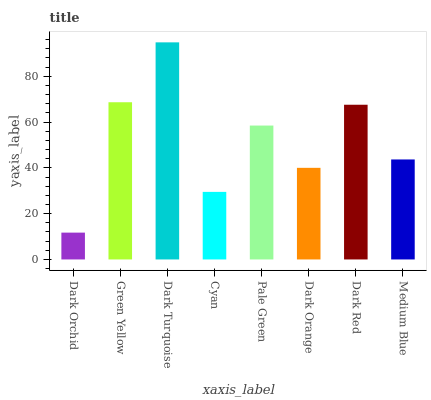Is Dark Orchid the minimum?
Answer yes or no. Yes. Is Dark Turquoise the maximum?
Answer yes or no. Yes. Is Green Yellow the minimum?
Answer yes or no. No. Is Green Yellow the maximum?
Answer yes or no. No. Is Green Yellow greater than Dark Orchid?
Answer yes or no. Yes. Is Dark Orchid less than Green Yellow?
Answer yes or no. Yes. Is Dark Orchid greater than Green Yellow?
Answer yes or no. No. Is Green Yellow less than Dark Orchid?
Answer yes or no. No. Is Pale Green the high median?
Answer yes or no. Yes. Is Medium Blue the low median?
Answer yes or no. Yes. Is Green Yellow the high median?
Answer yes or no. No. Is Dark Orange the low median?
Answer yes or no. No. 